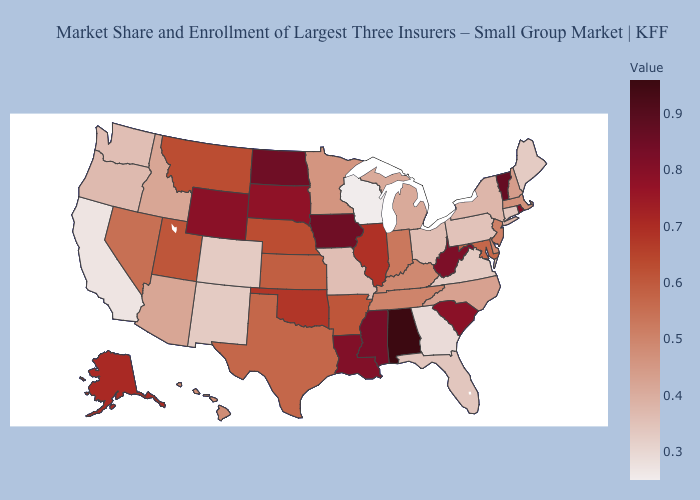Does the map have missing data?
Short answer required. No. Does North Carolina have the lowest value in the USA?
Be succinct. No. Which states have the lowest value in the MidWest?
Be succinct. Wisconsin. 